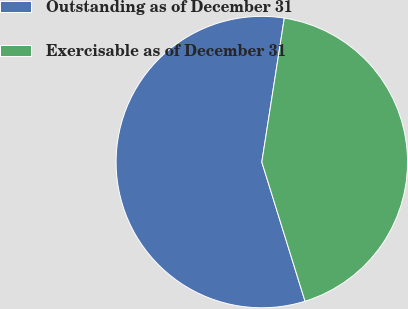Convert chart to OTSL. <chart><loc_0><loc_0><loc_500><loc_500><pie_chart><fcel>Outstanding as of December 31<fcel>Exercisable as of December 31<nl><fcel>57.26%<fcel>42.74%<nl></chart> 